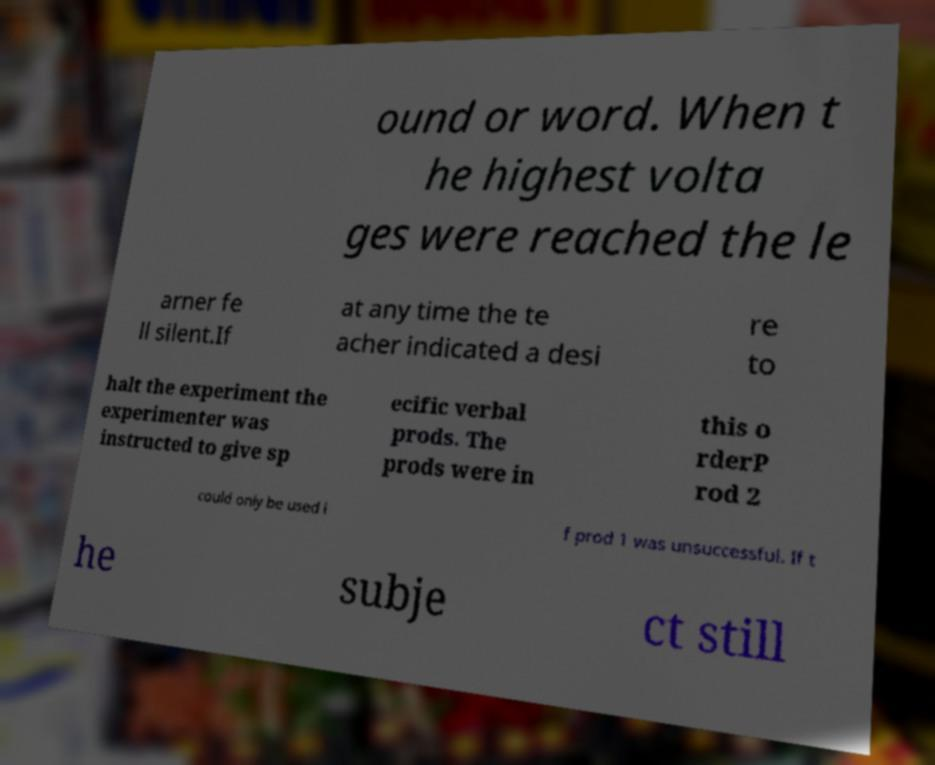Please read and relay the text visible in this image. What does it say? ound or word. When t he highest volta ges were reached the le arner fe ll silent.If at any time the te acher indicated a desi re to halt the experiment the experimenter was instructed to give sp ecific verbal prods. The prods were in this o rderP rod 2 could only be used i f prod 1 was unsuccessful. If t he subje ct still 